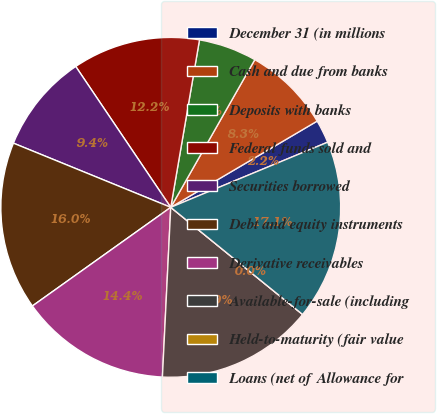Convert chart. <chart><loc_0><loc_0><loc_500><loc_500><pie_chart><fcel>December 31 (in millions<fcel>Cash and due from banks<fcel>Deposits with banks<fcel>Federal funds sold and<fcel>Securities borrowed<fcel>Debt and equity instruments<fcel>Derivative receivables<fcel>Available-for-sale (including<fcel>Held-to-maturity (fair value<fcel>Loans (net of Allowance for<nl><fcel>2.21%<fcel>8.29%<fcel>5.53%<fcel>12.15%<fcel>9.39%<fcel>16.02%<fcel>14.36%<fcel>14.92%<fcel>0.0%<fcel>17.12%<nl></chart> 